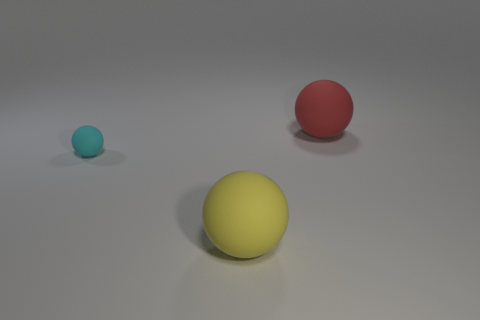What is the size of the thing to the left of the large object that is in front of the small sphere?
Offer a very short reply. Small. What number of other matte balls have the same size as the red rubber sphere?
Offer a terse response. 1. There is a large red rubber ball; are there any balls on the left side of it?
Your answer should be compact. Yes. What color is the sphere that is on the right side of the cyan rubber ball and left of the big red rubber thing?
Ensure brevity in your answer.  Yellow. Are the large thing that is in front of the small sphere and the red sphere on the right side of the cyan matte object made of the same material?
Provide a succinct answer. Yes. There is a thing on the left side of the yellow ball; what size is it?
Your answer should be compact. Small. The cyan sphere is what size?
Your response must be concise. Small. What size is the matte object that is on the right side of the large thing in front of the sphere to the left of the yellow rubber object?
Provide a succinct answer. Large. Is there a yellow ball made of the same material as the tiny cyan thing?
Offer a terse response. Yes. What is the color of the big thing that is the same material as the big yellow ball?
Provide a short and direct response. Red. 